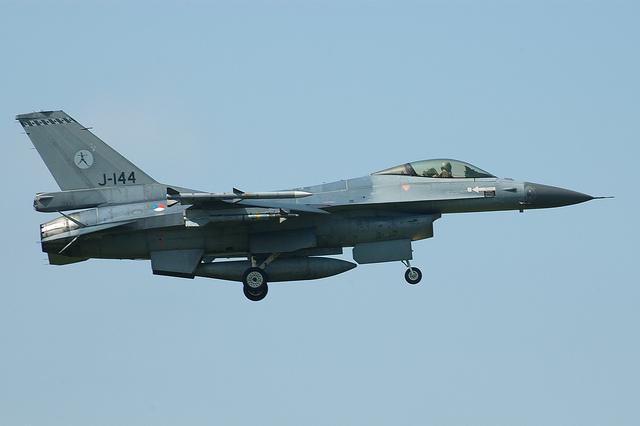What is the jet's serial number?
Keep it brief. J-144. Where are do you see J-144?
Keep it brief. Tail. How many wheels are on the jet?
Give a very brief answer. 3. Are the plane and the sky the same color?
Keep it brief. No. What kind of weapon is on the plane?
Concise answer only. Missile. What is the id number of the plane?
Quick response, please. J-144. 